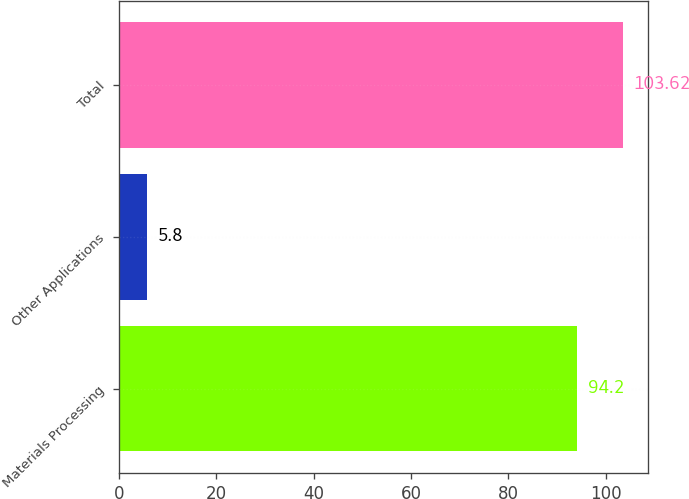Convert chart to OTSL. <chart><loc_0><loc_0><loc_500><loc_500><bar_chart><fcel>Materials Processing<fcel>Other Applications<fcel>Total<nl><fcel>94.2<fcel>5.8<fcel>103.62<nl></chart> 